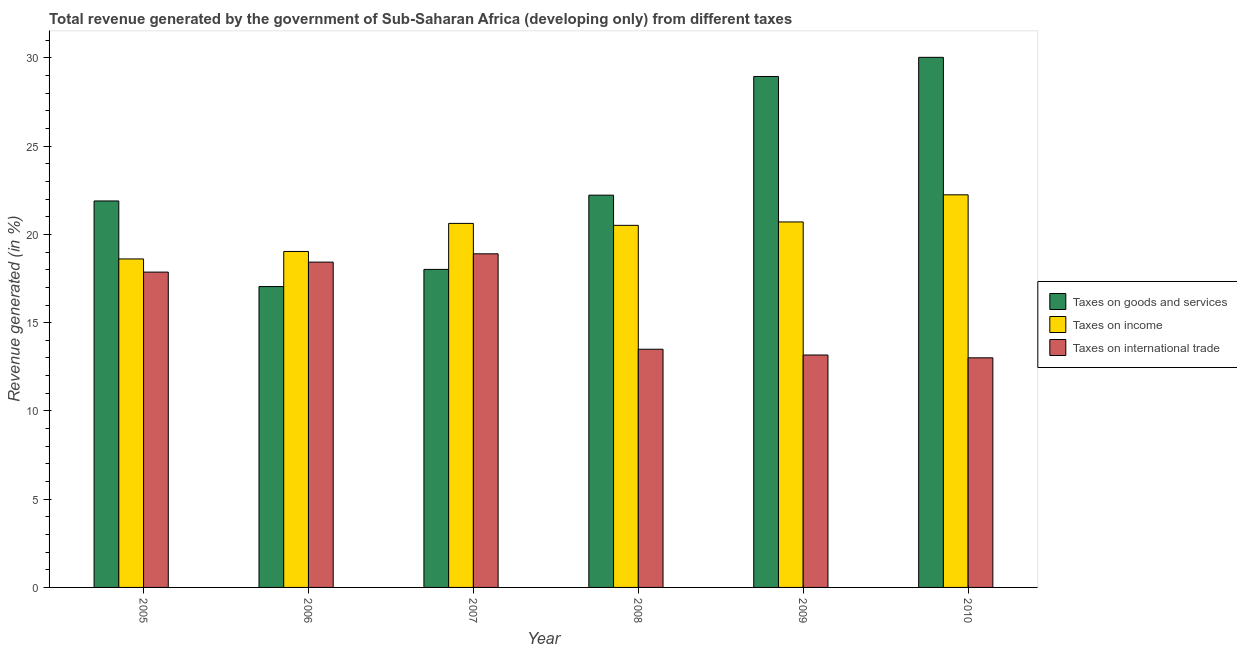How many groups of bars are there?
Ensure brevity in your answer.  6. Are the number of bars on each tick of the X-axis equal?
Keep it short and to the point. Yes. How many bars are there on the 5th tick from the left?
Make the answer very short. 3. How many bars are there on the 3rd tick from the right?
Keep it short and to the point. 3. What is the label of the 1st group of bars from the left?
Your answer should be very brief. 2005. What is the percentage of revenue generated by taxes on goods and services in 2005?
Make the answer very short. 21.9. Across all years, what is the maximum percentage of revenue generated by tax on international trade?
Your answer should be compact. 18.9. Across all years, what is the minimum percentage of revenue generated by taxes on income?
Your answer should be compact. 18.61. In which year was the percentage of revenue generated by tax on international trade minimum?
Your answer should be very brief. 2010. What is the total percentage of revenue generated by taxes on goods and services in the graph?
Your answer should be very brief. 138.18. What is the difference between the percentage of revenue generated by taxes on goods and services in 2007 and that in 2008?
Your answer should be compact. -4.21. What is the difference between the percentage of revenue generated by tax on international trade in 2007 and the percentage of revenue generated by taxes on income in 2008?
Make the answer very short. 5.41. What is the average percentage of revenue generated by taxes on goods and services per year?
Your answer should be very brief. 23.03. What is the ratio of the percentage of revenue generated by tax on international trade in 2006 to that in 2008?
Your answer should be compact. 1.37. Is the percentage of revenue generated by taxes on income in 2005 less than that in 2006?
Offer a terse response. Yes. Is the difference between the percentage of revenue generated by taxes on goods and services in 2006 and 2008 greater than the difference between the percentage of revenue generated by taxes on income in 2006 and 2008?
Your answer should be very brief. No. What is the difference between the highest and the second highest percentage of revenue generated by taxes on income?
Your response must be concise. 1.54. What is the difference between the highest and the lowest percentage of revenue generated by tax on international trade?
Offer a terse response. 5.89. Is the sum of the percentage of revenue generated by taxes on income in 2005 and 2009 greater than the maximum percentage of revenue generated by tax on international trade across all years?
Offer a terse response. Yes. What does the 1st bar from the left in 2009 represents?
Make the answer very short. Taxes on goods and services. What does the 1st bar from the right in 2007 represents?
Ensure brevity in your answer.  Taxes on international trade. What is the difference between two consecutive major ticks on the Y-axis?
Your answer should be compact. 5. Are the values on the major ticks of Y-axis written in scientific E-notation?
Provide a succinct answer. No. What is the title of the graph?
Provide a short and direct response. Total revenue generated by the government of Sub-Saharan Africa (developing only) from different taxes. What is the label or title of the X-axis?
Give a very brief answer. Year. What is the label or title of the Y-axis?
Give a very brief answer. Revenue generated (in %). What is the Revenue generated (in %) in Taxes on goods and services in 2005?
Offer a very short reply. 21.9. What is the Revenue generated (in %) of Taxes on income in 2005?
Keep it short and to the point. 18.61. What is the Revenue generated (in %) in Taxes on international trade in 2005?
Give a very brief answer. 17.87. What is the Revenue generated (in %) of Taxes on goods and services in 2006?
Provide a succinct answer. 17.05. What is the Revenue generated (in %) of Taxes on income in 2006?
Offer a terse response. 19.04. What is the Revenue generated (in %) of Taxes on international trade in 2006?
Provide a succinct answer. 18.43. What is the Revenue generated (in %) of Taxes on goods and services in 2007?
Make the answer very short. 18.02. What is the Revenue generated (in %) of Taxes on income in 2007?
Ensure brevity in your answer.  20.63. What is the Revenue generated (in %) in Taxes on international trade in 2007?
Your answer should be very brief. 18.9. What is the Revenue generated (in %) of Taxes on goods and services in 2008?
Offer a terse response. 22.23. What is the Revenue generated (in %) in Taxes on income in 2008?
Give a very brief answer. 20.52. What is the Revenue generated (in %) in Taxes on international trade in 2008?
Offer a very short reply. 13.5. What is the Revenue generated (in %) of Taxes on goods and services in 2009?
Offer a terse response. 28.95. What is the Revenue generated (in %) in Taxes on income in 2009?
Provide a succinct answer. 20.71. What is the Revenue generated (in %) of Taxes on international trade in 2009?
Your response must be concise. 13.17. What is the Revenue generated (in %) in Taxes on goods and services in 2010?
Provide a succinct answer. 30.04. What is the Revenue generated (in %) of Taxes on income in 2010?
Make the answer very short. 22.25. What is the Revenue generated (in %) of Taxes on international trade in 2010?
Ensure brevity in your answer.  13.01. Across all years, what is the maximum Revenue generated (in %) of Taxes on goods and services?
Your answer should be compact. 30.04. Across all years, what is the maximum Revenue generated (in %) in Taxes on income?
Your response must be concise. 22.25. Across all years, what is the maximum Revenue generated (in %) of Taxes on international trade?
Your response must be concise. 18.9. Across all years, what is the minimum Revenue generated (in %) of Taxes on goods and services?
Make the answer very short. 17.05. Across all years, what is the minimum Revenue generated (in %) in Taxes on income?
Offer a very short reply. 18.61. Across all years, what is the minimum Revenue generated (in %) of Taxes on international trade?
Keep it short and to the point. 13.01. What is the total Revenue generated (in %) of Taxes on goods and services in the graph?
Your response must be concise. 138.18. What is the total Revenue generated (in %) of Taxes on income in the graph?
Make the answer very short. 121.75. What is the total Revenue generated (in %) in Taxes on international trade in the graph?
Give a very brief answer. 94.88. What is the difference between the Revenue generated (in %) of Taxes on goods and services in 2005 and that in 2006?
Provide a succinct answer. 4.85. What is the difference between the Revenue generated (in %) in Taxes on income in 2005 and that in 2006?
Keep it short and to the point. -0.42. What is the difference between the Revenue generated (in %) in Taxes on international trade in 2005 and that in 2006?
Offer a very short reply. -0.57. What is the difference between the Revenue generated (in %) in Taxes on goods and services in 2005 and that in 2007?
Provide a succinct answer. 3.88. What is the difference between the Revenue generated (in %) in Taxes on income in 2005 and that in 2007?
Provide a succinct answer. -2.01. What is the difference between the Revenue generated (in %) in Taxes on international trade in 2005 and that in 2007?
Keep it short and to the point. -1.04. What is the difference between the Revenue generated (in %) in Taxes on goods and services in 2005 and that in 2008?
Make the answer very short. -0.33. What is the difference between the Revenue generated (in %) in Taxes on income in 2005 and that in 2008?
Provide a succinct answer. -1.9. What is the difference between the Revenue generated (in %) in Taxes on international trade in 2005 and that in 2008?
Keep it short and to the point. 4.37. What is the difference between the Revenue generated (in %) in Taxes on goods and services in 2005 and that in 2009?
Provide a succinct answer. -7.05. What is the difference between the Revenue generated (in %) in Taxes on income in 2005 and that in 2009?
Provide a short and direct response. -2.1. What is the difference between the Revenue generated (in %) in Taxes on international trade in 2005 and that in 2009?
Offer a very short reply. 4.7. What is the difference between the Revenue generated (in %) of Taxes on goods and services in 2005 and that in 2010?
Offer a terse response. -8.14. What is the difference between the Revenue generated (in %) in Taxes on income in 2005 and that in 2010?
Your answer should be compact. -3.63. What is the difference between the Revenue generated (in %) in Taxes on international trade in 2005 and that in 2010?
Ensure brevity in your answer.  4.86. What is the difference between the Revenue generated (in %) in Taxes on goods and services in 2006 and that in 2007?
Make the answer very short. -0.97. What is the difference between the Revenue generated (in %) in Taxes on income in 2006 and that in 2007?
Offer a very short reply. -1.59. What is the difference between the Revenue generated (in %) of Taxes on international trade in 2006 and that in 2007?
Provide a short and direct response. -0.47. What is the difference between the Revenue generated (in %) of Taxes on goods and services in 2006 and that in 2008?
Ensure brevity in your answer.  -5.18. What is the difference between the Revenue generated (in %) in Taxes on income in 2006 and that in 2008?
Your answer should be very brief. -1.48. What is the difference between the Revenue generated (in %) in Taxes on international trade in 2006 and that in 2008?
Ensure brevity in your answer.  4.94. What is the difference between the Revenue generated (in %) of Taxes on goods and services in 2006 and that in 2009?
Your answer should be compact. -11.9. What is the difference between the Revenue generated (in %) in Taxes on income in 2006 and that in 2009?
Your answer should be compact. -1.67. What is the difference between the Revenue generated (in %) in Taxes on international trade in 2006 and that in 2009?
Provide a succinct answer. 5.26. What is the difference between the Revenue generated (in %) in Taxes on goods and services in 2006 and that in 2010?
Offer a terse response. -12.99. What is the difference between the Revenue generated (in %) of Taxes on income in 2006 and that in 2010?
Ensure brevity in your answer.  -3.21. What is the difference between the Revenue generated (in %) in Taxes on international trade in 2006 and that in 2010?
Provide a short and direct response. 5.42. What is the difference between the Revenue generated (in %) of Taxes on goods and services in 2007 and that in 2008?
Your answer should be very brief. -4.21. What is the difference between the Revenue generated (in %) in Taxes on income in 2007 and that in 2008?
Offer a very short reply. 0.11. What is the difference between the Revenue generated (in %) of Taxes on international trade in 2007 and that in 2008?
Offer a terse response. 5.41. What is the difference between the Revenue generated (in %) of Taxes on goods and services in 2007 and that in 2009?
Make the answer very short. -10.93. What is the difference between the Revenue generated (in %) in Taxes on income in 2007 and that in 2009?
Provide a succinct answer. -0.08. What is the difference between the Revenue generated (in %) of Taxes on international trade in 2007 and that in 2009?
Your answer should be compact. 5.73. What is the difference between the Revenue generated (in %) of Taxes on goods and services in 2007 and that in 2010?
Your response must be concise. -12.02. What is the difference between the Revenue generated (in %) of Taxes on income in 2007 and that in 2010?
Give a very brief answer. -1.62. What is the difference between the Revenue generated (in %) of Taxes on international trade in 2007 and that in 2010?
Make the answer very short. 5.89. What is the difference between the Revenue generated (in %) in Taxes on goods and services in 2008 and that in 2009?
Your answer should be very brief. -6.72. What is the difference between the Revenue generated (in %) of Taxes on income in 2008 and that in 2009?
Keep it short and to the point. -0.19. What is the difference between the Revenue generated (in %) in Taxes on international trade in 2008 and that in 2009?
Your response must be concise. 0.33. What is the difference between the Revenue generated (in %) in Taxes on goods and services in 2008 and that in 2010?
Provide a succinct answer. -7.81. What is the difference between the Revenue generated (in %) in Taxes on income in 2008 and that in 2010?
Offer a terse response. -1.73. What is the difference between the Revenue generated (in %) of Taxes on international trade in 2008 and that in 2010?
Provide a short and direct response. 0.49. What is the difference between the Revenue generated (in %) in Taxes on goods and services in 2009 and that in 2010?
Provide a succinct answer. -1.09. What is the difference between the Revenue generated (in %) in Taxes on income in 2009 and that in 2010?
Your answer should be very brief. -1.54. What is the difference between the Revenue generated (in %) of Taxes on international trade in 2009 and that in 2010?
Keep it short and to the point. 0.16. What is the difference between the Revenue generated (in %) of Taxes on goods and services in 2005 and the Revenue generated (in %) of Taxes on income in 2006?
Offer a very short reply. 2.86. What is the difference between the Revenue generated (in %) in Taxes on goods and services in 2005 and the Revenue generated (in %) in Taxes on international trade in 2006?
Provide a short and direct response. 3.47. What is the difference between the Revenue generated (in %) in Taxes on income in 2005 and the Revenue generated (in %) in Taxes on international trade in 2006?
Make the answer very short. 0.18. What is the difference between the Revenue generated (in %) in Taxes on goods and services in 2005 and the Revenue generated (in %) in Taxes on income in 2007?
Your response must be concise. 1.27. What is the difference between the Revenue generated (in %) of Taxes on goods and services in 2005 and the Revenue generated (in %) of Taxes on international trade in 2007?
Make the answer very short. 3. What is the difference between the Revenue generated (in %) of Taxes on income in 2005 and the Revenue generated (in %) of Taxes on international trade in 2007?
Make the answer very short. -0.29. What is the difference between the Revenue generated (in %) in Taxes on goods and services in 2005 and the Revenue generated (in %) in Taxes on income in 2008?
Keep it short and to the point. 1.38. What is the difference between the Revenue generated (in %) in Taxes on goods and services in 2005 and the Revenue generated (in %) in Taxes on international trade in 2008?
Your answer should be very brief. 8.4. What is the difference between the Revenue generated (in %) of Taxes on income in 2005 and the Revenue generated (in %) of Taxes on international trade in 2008?
Make the answer very short. 5.12. What is the difference between the Revenue generated (in %) in Taxes on goods and services in 2005 and the Revenue generated (in %) in Taxes on income in 2009?
Make the answer very short. 1.19. What is the difference between the Revenue generated (in %) of Taxes on goods and services in 2005 and the Revenue generated (in %) of Taxes on international trade in 2009?
Your answer should be very brief. 8.73. What is the difference between the Revenue generated (in %) of Taxes on income in 2005 and the Revenue generated (in %) of Taxes on international trade in 2009?
Offer a terse response. 5.44. What is the difference between the Revenue generated (in %) in Taxes on goods and services in 2005 and the Revenue generated (in %) in Taxes on income in 2010?
Keep it short and to the point. -0.35. What is the difference between the Revenue generated (in %) in Taxes on goods and services in 2005 and the Revenue generated (in %) in Taxes on international trade in 2010?
Ensure brevity in your answer.  8.89. What is the difference between the Revenue generated (in %) in Taxes on income in 2005 and the Revenue generated (in %) in Taxes on international trade in 2010?
Make the answer very short. 5.6. What is the difference between the Revenue generated (in %) in Taxes on goods and services in 2006 and the Revenue generated (in %) in Taxes on income in 2007?
Provide a short and direct response. -3.58. What is the difference between the Revenue generated (in %) of Taxes on goods and services in 2006 and the Revenue generated (in %) of Taxes on international trade in 2007?
Give a very brief answer. -1.86. What is the difference between the Revenue generated (in %) of Taxes on income in 2006 and the Revenue generated (in %) of Taxes on international trade in 2007?
Offer a terse response. 0.13. What is the difference between the Revenue generated (in %) in Taxes on goods and services in 2006 and the Revenue generated (in %) in Taxes on income in 2008?
Give a very brief answer. -3.47. What is the difference between the Revenue generated (in %) of Taxes on goods and services in 2006 and the Revenue generated (in %) of Taxes on international trade in 2008?
Your answer should be compact. 3.55. What is the difference between the Revenue generated (in %) in Taxes on income in 2006 and the Revenue generated (in %) in Taxes on international trade in 2008?
Your answer should be compact. 5.54. What is the difference between the Revenue generated (in %) in Taxes on goods and services in 2006 and the Revenue generated (in %) in Taxes on income in 2009?
Keep it short and to the point. -3.66. What is the difference between the Revenue generated (in %) in Taxes on goods and services in 2006 and the Revenue generated (in %) in Taxes on international trade in 2009?
Offer a terse response. 3.88. What is the difference between the Revenue generated (in %) in Taxes on income in 2006 and the Revenue generated (in %) in Taxes on international trade in 2009?
Offer a terse response. 5.87. What is the difference between the Revenue generated (in %) in Taxes on goods and services in 2006 and the Revenue generated (in %) in Taxes on income in 2010?
Your response must be concise. -5.2. What is the difference between the Revenue generated (in %) in Taxes on goods and services in 2006 and the Revenue generated (in %) in Taxes on international trade in 2010?
Make the answer very short. 4.04. What is the difference between the Revenue generated (in %) in Taxes on income in 2006 and the Revenue generated (in %) in Taxes on international trade in 2010?
Provide a succinct answer. 6.03. What is the difference between the Revenue generated (in %) of Taxes on goods and services in 2007 and the Revenue generated (in %) of Taxes on income in 2008?
Offer a very short reply. -2.5. What is the difference between the Revenue generated (in %) in Taxes on goods and services in 2007 and the Revenue generated (in %) in Taxes on international trade in 2008?
Your answer should be compact. 4.52. What is the difference between the Revenue generated (in %) of Taxes on income in 2007 and the Revenue generated (in %) of Taxes on international trade in 2008?
Give a very brief answer. 7.13. What is the difference between the Revenue generated (in %) in Taxes on goods and services in 2007 and the Revenue generated (in %) in Taxes on income in 2009?
Keep it short and to the point. -2.69. What is the difference between the Revenue generated (in %) of Taxes on goods and services in 2007 and the Revenue generated (in %) of Taxes on international trade in 2009?
Make the answer very short. 4.85. What is the difference between the Revenue generated (in %) of Taxes on income in 2007 and the Revenue generated (in %) of Taxes on international trade in 2009?
Give a very brief answer. 7.46. What is the difference between the Revenue generated (in %) of Taxes on goods and services in 2007 and the Revenue generated (in %) of Taxes on income in 2010?
Offer a terse response. -4.23. What is the difference between the Revenue generated (in %) in Taxes on goods and services in 2007 and the Revenue generated (in %) in Taxes on international trade in 2010?
Give a very brief answer. 5.01. What is the difference between the Revenue generated (in %) in Taxes on income in 2007 and the Revenue generated (in %) in Taxes on international trade in 2010?
Provide a succinct answer. 7.62. What is the difference between the Revenue generated (in %) in Taxes on goods and services in 2008 and the Revenue generated (in %) in Taxes on income in 2009?
Provide a succinct answer. 1.52. What is the difference between the Revenue generated (in %) in Taxes on goods and services in 2008 and the Revenue generated (in %) in Taxes on international trade in 2009?
Give a very brief answer. 9.06. What is the difference between the Revenue generated (in %) in Taxes on income in 2008 and the Revenue generated (in %) in Taxes on international trade in 2009?
Ensure brevity in your answer.  7.35. What is the difference between the Revenue generated (in %) of Taxes on goods and services in 2008 and the Revenue generated (in %) of Taxes on income in 2010?
Give a very brief answer. -0.02. What is the difference between the Revenue generated (in %) in Taxes on goods and services in 2008 and the Revenue generated (in %) in Taxes on international trade in 2010?
Offer a very short reply. 9.22. What is the difference between the Revenue generated (in %) in Taxes on income in 2008 and the Revenue generated (in %) in Taxes on international trade in 2010?
Provide a succinct answer. 7.51. What is the difference between the Revenue generated (in %) in Taxes on goods and services in 2009 and the Revenue generated (in %) in Taxes on income in 2010?
Your answer should be very brief. 6.71. What is the difference between the Revenue generated (in %) in Taxes on goods and services in 2009 and the Revenue generated (in %) in Taxes on international trade in 2010?
Keep it short and to the point. 15.94. What is the difference between the Revenue generated (in %) of Taxes on income in 2009 and the Revenue generated (in %) of Taxes on international trade in 2010?
Offer a terse response. 7.7. What is the average Revenue generated (in %) of Taxes on goods and services per year?
Offer a terse response. 23.03. What is the average Revenue generated (in %) in Taxes on income per year?
Keep it short and to the point. 20.29. What is the average Revenue generated (in %) of Taxes on international trade per year?
Make the answer very short. 15.81. In the year 2005, what is the difference between the Revenue generated (in %) of Taxes on goods and services and Revenue generated (in %) of Taxes on income?
Offer a very short reply. 3.29. In the year 2005, what is the difference between the Revenue generated (in %) in Taxes on goods and services and Revenue generated (in %) in Taxes on international trade?
Ensure brevity in your answer.  4.03. In the year 2005, what is the difference between the Revenue generated (in %) in Taxes on income and Revenue generated (in %) in Taxes on international trade?
Make the answer very short. 0.75. In the year 2006, what is the difference between the Revenue generated (in %) in Taxes on goods and services and Revenue generated (in %) in Taxes on income?
Give a very brief answer. -1.99. In the year 2006, what is the difference between the Revenue generated (in %) in Taxes on goods and services and Revenue generated (in %) in Taxes on international trade?
Your answer should be compact. -1.39. In the year 2006, what is the difference between the Revenue generated (in %) of Taxes on income and Revenue generated (in %) of Taxes on international trade?
Provide a succinct answer. 0.6. In the year 2007, what is the difference between the Revenue generated (in %) of Taxes on goods and services and Revenue generated (in %) of Taxes on income?
Make the answer very short. -2.61. In the year 2007, what is the difference between the Revenue generated (in %) of Taxes on goods and services and Revenue generated (in %) of Taxes on international trade?
Offer a very short reply. -0.88. In the year 2007, what is the difference between the Revenue generated (in %) of Taxes on income and Revenue generated (in %) of Taxes on international trade?
Ensure brevity in your answer.  1.72. In the year 2008, what is the difference between the Revenue generated (in %) of Taxes on goods and services and Revenue generated (in %) of Taxes on income?
Your answer should be compact. 1.71. In the year 2008, what is the difference between the Revenue generated (in %) in Taxes on goods and services and Revenue generated (in %) in Taxes on international trade?
Your response must be concise. 8.73. In the year 2008, what is the difference between the Revenue generated (in %) in Taxes on income and Revenue generated (in %) in Taxes on international trade?
Your answer should be very brief. 7.02. In the year 2009, what is the difference between the Revenue generated (in %) in Taxes on goods and services and Revenue generated (in %) in Taxes on income?
Your answer should be compact. 8.24. In the year 2009, what is the difference between the Revenue generated (in %) of Taxes on goods and services and Revenue generated (in %) of Taxes on international trade?
Give a very brief answer. 15.78. In the year 2009, what is the difference between the Revenue generated (in %) of Taxes on income and Revenue generated (in %) of Taxes on international trade?
Offer a very short reply. 7.54. In the year 2010, what is the difference between the Revenue generated (in %) in Taxes on goods and services and Revenue generated (in %) in Taxes on income?
Provide a succinct answer. 7.79. In the year 2010, what is the difference between the Revenue generated (in %) of Taxes on goods and services and Revenue generated (in %) of Taxes on international trade?
Offer a very short reply. 17.03. In the year 2010, what is the difference between the Revenue generated (in %) of Taxes on income and Revenue generated (in %) of Taxes on international trade?
Ensure brevity in your answer.  9.24. What is the ratio of the Revenue generated (in %) in Taxes on goods and services in 2005 to that in 2006?
Offer a terse response. 1.28. What is the ratio of the Revenue generated (in %) of Taxes on income in 2005 to that in 2006?
Your response must be concise. 0.98. What is the ratio of the Revenue generated (in %) in Taxes on international trade in 2005 to that in 2006?
Your response must be concise. 0.97. What is the ratio of the Revenue generated (in %) of Taxes on goods and services in 2005 to that in 2007?
Your answer should be very brief. 1.22. What is the ratio of the Revenue generated (in %) in Taxes on income in 2005 to that in 2007?
Provide a succinct answer. 0.9. What is the ratio of the Revenue generated (in %) in Taxes on international trade in 2005 to that in 2007?
Keep it short and to the point. 0.95. What is the ratio of the Revenue generated (in %) of Taxes on goods and services in 2005 to that in 2008?
Your answer should be compact. 0.99. What is the ratio of the Revenue generated (in %) of Taxes on income in 2005 to that in 2008?
Your answer should be very brief. 0.91. What is the ratio of the Revenue generated (in %) of Taxes on international trade in 2005 to that in 2008?
Your answer should be compact. 1.32. What is the ratio of the Revenue generated (in %) in Taxes on goods and services in 2005 to that in 2009?
Make the answer very short. 0.76. What is the ratio of the Revenue generated (in %) in Taxes on income in 2005 to that in 2009?
Your answer should be compact. 0.9. What is the ratio of the Revenue generated (in %) of Taxes on international trade in 2005 to that in 2009?
Offer a terse response. 1.36. What is the ratio of the Revenue generated (in %) of Taxes on goods and services in 2005 to that in 2010?
Offer a terse response. 0.73. What is the ratio of the Revenue generated (in %) of Taxes on income in 2005 to that in 2010?
Your answer should be very brief. 0.84. What is the ratio of the Revenue generated (in %) of Taxes on international trade in 2005 to that in 2010?
Make the answer very short. 1.37. What is the ratio of the Revenue generated (in %) in Taxes on goods and services in 2006 to that in 2007?
Your answer should be very brief. 0.95. What is the ratio of the Revenue generated (in %) of Taxes on income in 2006 to that in 2007?
Your answer should be very brief. 0.92. What is the ratio of the Revenue generated (in %) of Taxes on international trade in 2006 to that in 2007?
Offer a very short reply. 0.98. What is the ratio of the Revenue generated (in %) in Taxes on goods and services in 2006 to that in 2008?
Give a very brief answer. 0.77. What is the ratio of the Revenue generated (in %) in Taxes on income in 2006 to that in 2008?
Ensure brevity in your answer.  0.93. What is the ratio of the Revenue generated (in %) in Taxes on international trade in 2006 to that in 2008?
Offer a terse response. 1.37. What is the ratio of the Revenue generated (in %) in Taxes on goods and services in 2006 to that in 2009?
Ensure brevity in your answer.  0.59. What is the ratio of the Revenue generated (in %) of Taxes on income in 2006 to that in 2009?
Keep it short and to the point. 0.92. What is the ratio of the Revenue generated (in %) of Taxes on international trade in 2006 to that in 2009?
Your answer should be very brief. 1.4. What is the ratio of the Revenue generated (in %) of Taxes on goods and services in 2006 to that in 2010?
Offer a terse response. 0.57. What is the ratio of the Revenue generated (in %) in Taxes on income in 2006 to that in 2010?
Provide a short and direct response. 0.86. What is the ratio of the Revenue generated (in %) in Taxes on international trade in 2006 to that in 2010?
Offer a very short reply. 1.42. What is the ratio of the Revenue generated (in %) in Taxes on goods and services in 2007 to that in 2008?
Your answer should be compact. 0.81. What is the ratio of the Revenue generated (in %) in Taxes on income in 2007 to that in 2008?
Keep it short and to the point. 1.01. What is the ratio of the Revenue generated (in %) in Taxes on international trade in 2007 to that in 2008?
Make the answer very short. 1.4. What is the ratio of the Revenue generated (in %) in Taxes on goods and services in 2007 to that in 2009?
Your response must be concise. 0.62. What is the ratio of the Revenue generated (in %) in Taxes on international trade in 2007 to that in 2009?
Your response must be concise. 1.44. What is the ratio of the Revenue generated (in %) in Taxes on goods and services in 2007 to that in 2010?
Provide a short and direct response. 0.6. What is the ratio of the Revenue generated (in %) of Taxes on income in 2007 to that in 2010?
Offer a very short reply. 0.93. What is the ratio of the Revenue generated (in %) in Taxes on international trade in 2007 to that in 2010?
Your response must be concise. 1.45. What is the ratio of the Revenue generated (in %) of Taxes on goods and services in 2008 to that in 2009?
Ensure brevity in your answer.  0.77. What is the ratio of the Revenue generated (in %) in Taxes on income in 2008 to that in 2009?
Offer a very short reply. 0.99. What is the ratio of the Revenue generated (in %) of Taxes on international trade in 2008 to that in 2009?
Keep it short and to the point. 1.02. What is the ratio of the Revenue generated (in %) of Taxes on goods and services in 2008 to that in 2010?
Keep it short and to the point. 0.74. What is the ratio of the Revenue generated (in %) of Taxes on income in 2008 to that in 2010?
Keep it short and to the point. 0.92. What is the ratio of the Revenue generated (in %) in Taxes on international trade in 2008 to that in 2010?
Ensure brevity in your answer.  1.04. What is the ratio of the Revenue generated (in %) of Taxes on goods and services in 2009 to that in 2010?
Provide a succinct answer. 0.96. What is the ratio of the Revenue generated (in %) of Taxes on income in 2009 to that in 2010?
Your answer should be very brief. 0.93. What is the ratio of the Revenue generated (in %) of Taxes on international trade in 2009 to that in 2010?
Provide a succinct answer. 1.01. What is the difference between the highest and the second highest Revenue generated (in %) in Taxes on goods and services?
Offer a very short reply. 1.09. What is the difference between the highest and the second highest Revenue generated (in %) in Taxes on income?
Keep it short and to the point. 1.54. What is the difference between the highest and the second highest Revenue generated (in %) in Taxes on international trade?
Your answer should be compact. 0.47. What is the difference between the highest and the lowest Revenue generated (in %) of Taxes on goods and services?
Provide a succinct answer. 12.99. What is the difference between the highest and the lowest Revenue generated (in %) in Taxes on income?
Offer a terse response. 3.63. What is the difference between the highest and the lowest Revenue generated (in %) of Taxes on international trade?
Your answer should be compact. 5.89. 